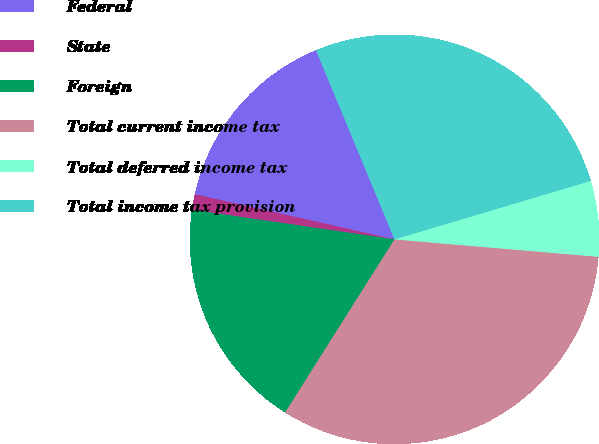Convert chart to OTSL. <chart><loc_0><loc_0><loc_500><loc_500><pie_chart><fcel>Federal<fcel>State<fcel>Foreign<fcel>Total current income tax<fcel>Total deferred income tax<fcel>Total income tax provision<nl><fcel>15.2%<fcel>1.23%<fcel>18.34%<fcel>32.61%<fcel>5.96%<fcel>26.65%<nl></chart> 